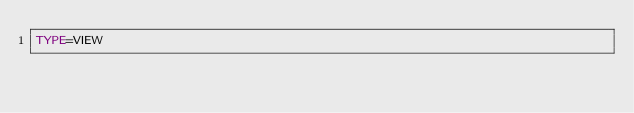Convert code to text. <code><loc_0><loc_0><loc_500><loc_500><_VisualBasic_>TYPE=VIEW</code> 